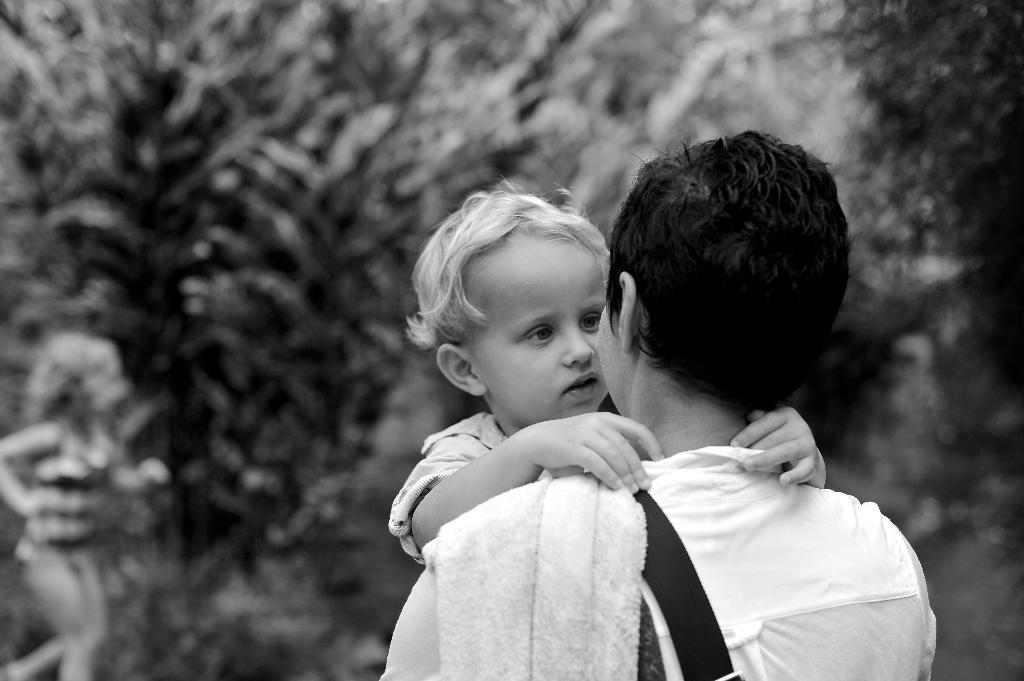What is the main subject in the middle of the image? There is a person in the middle of the image. What is the person wearing? The person is wearing a shirt and cloth. What is the person doing in the image? The person is holding a baby. What can be seen in the background of the image? There are trees and a girl in the background of the image. What type of hydrant is present in the image? There is no hydrant present in the image. What government policies are being discussed in the image? There is no discussion of government policies in the image. 